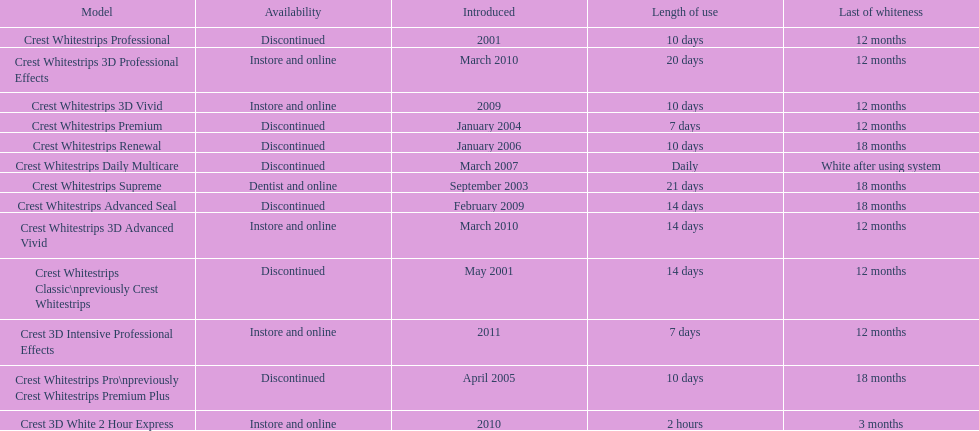Which discontinued product was introduced the same year as crest whitestrips 3d vivid? Crest Whitestrips Advanced Seal. 